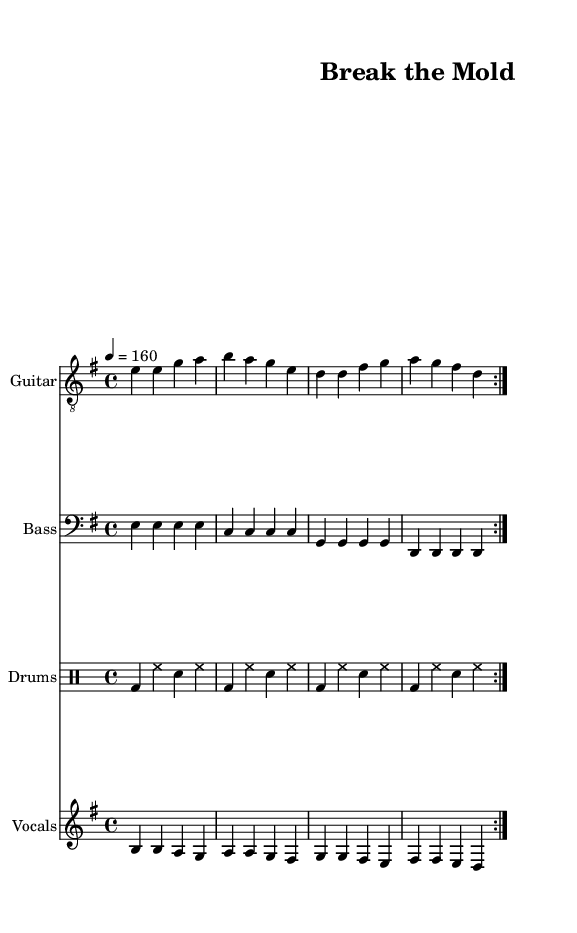What is the key signature of this music? The key signature is identified by the number of sharps or flats at the beginning of the staff, indicated by the glyphs. In this case, the key signature shows one sharp (F#), which indicates that the music is in E minor.
Answer: E minor What is the time signature of this music? The time signature is found at the beginning of the staff, shown as two numbers stacked vertically. Here, the time signature is 4 over 4, meaning there are four beats in a measure.
Answer: 4/4 What is the tempo marking of this music? The tempo marking is indicated by a numeric value which shows the beats per minute. In this piece, the tempo notation states "4 = 160," meaning that there are 160 quarter-note beats in one minute.
Answer: 160 How many measures are repeated in the main sections of this music? The repeated sections are indicated by the "volta" markings and the structure noted in the parts, which both indicate that the measures are repeated twice throughout different sections.
Answer: 2 What is the vocal range for this song? The vocal part is shown in the treble clef, and its highest pitch is B4 while the lowest is D4, which indicates a range suitable for a tenor or higher voice type.
Answer: B4 to D4 What is the common instrument used for rhythmic support in this piece? The instrument specifically dedicated to providing rhythmic support is the drums, which are notated on a separate staff and follow a standard drum notation pattern.
Answer: Drums What prominent theme does this song title suggest? The title "Break the Mold" suggests a theme of challenging societal expectations and promoting individual authenticity, which aligns with punk music philosophies.
Answer: Individual authenticity 